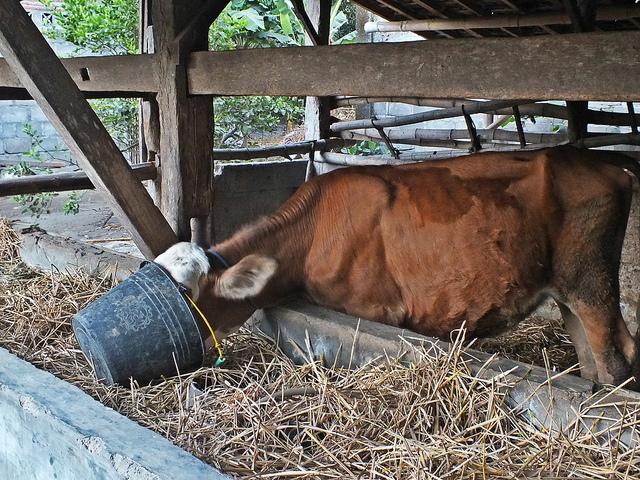What color is the cow?
Give a very brief answer. Brown. What type of animal is this?
Quick response, please. Cow. What type of food is in the gate?
Concise answer only. Hay. Is the cow feeding a calf?
Concise answer only. No. Is the cow eating or moving the bucket?
Give a very brief answer. Eating. What is around the cow's neck?
Concise answer only. Collar. Can the cow remove his head?
Answer briefly. Yes. 